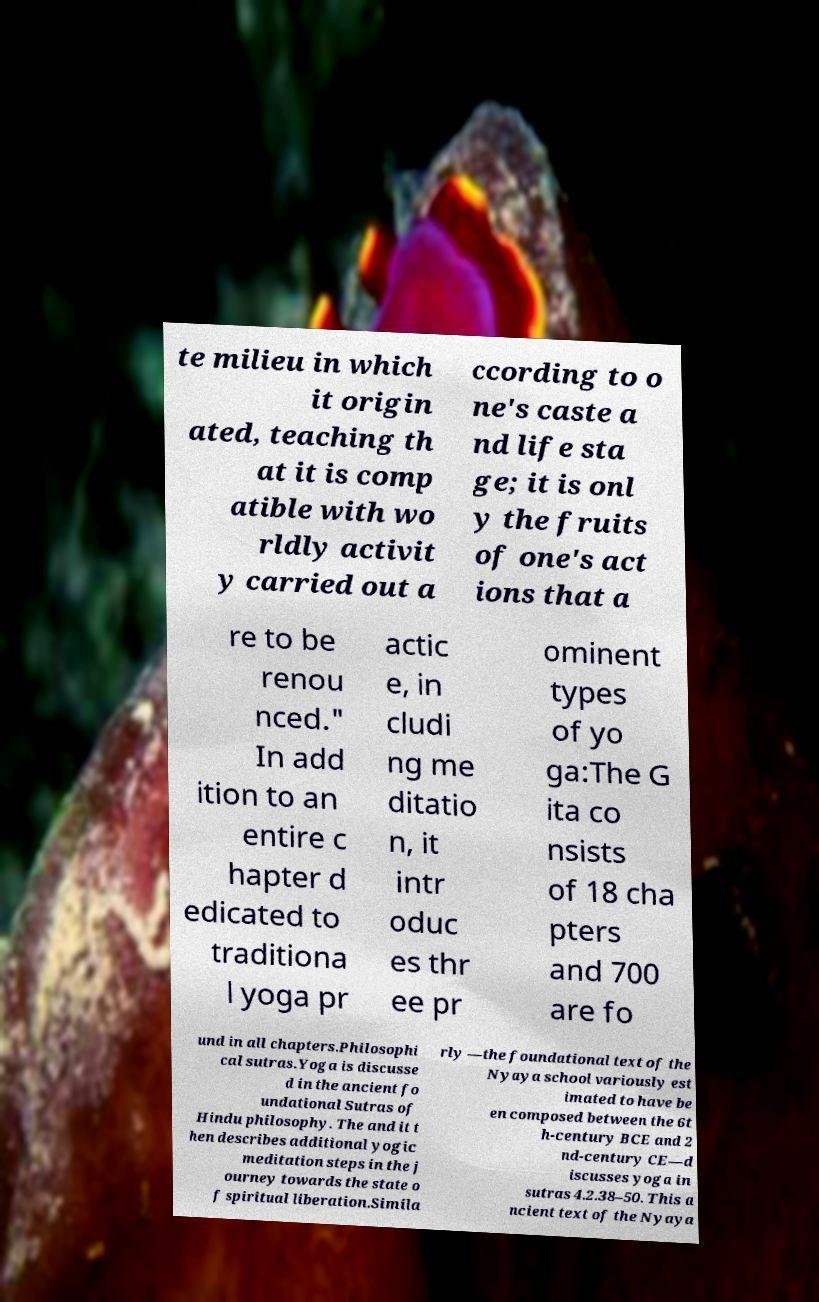Can you accurately transcribe the text from the provided image for me? te milieu in which it origin ated, teaching th at it is comp atible with wo rldly activit y carried out a ccording to o ne's caste a nd life sta ge; it is onl y the fruits of one's act ions that a re to be renou nced." In add ition to an entire c hapter d edicated to traditiona l yoga pr actic e, in cludi ng me ditatio n, it intr oduc es thr ee pr ominent types of yo ga:The G ita co nsists of 18 cha pters and 700 are fo und in all chapters.Philosophi cal sutras.Yoga is discusse d in the ancient fo undational Sutras of Hindu philosophy. The and it t hen describes additional yogic meditation steps in the j ourney towards the state o f spiritual liberation.Simila rly —the foundational text of the Nyaya school variously est imated to have be en composed between the 6t h-century BCE and 2 nd-century CE—d iscusses yoga in sutras 4.2.38–50. This a ncient text of the Nyaya 